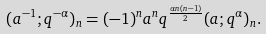<formula> <loc_0><loc_0><loc_500><loc_500>( a ^ { - 1 } ; q ^ { - \alpha } ) _ { n } = ( - 1 ) ^ { n } a ^ { n } q ^ { \frac { \alpha n ( n - 1 ) } { 2 } } ( a ; q ^ { \alpha } ) _ { n } .</formula> 